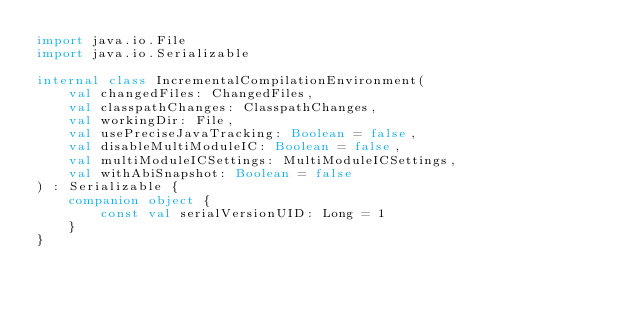<code> <loc_0><loc_0><loc_500><loc_500><_Kotlin_>import java.io.File
import java.io.Serializable

internal class IncrementalCompilationEnvironment(
    val changedFiles: ChangedFiles,
    val classpathChanges: ClasspathChanges,
    val workingDir: File,
    val usePreciseJavaTracking: Boolean = false,
    val disableMultiModuleIC: Boolean = false,
    val multiModuleICSettings: MultiModuleICSettings,
    val withAbiSnapshot: Boolean = false
) : Serializable {
    companion object {
        const val serialVersionUID: Long = 1
    }
}</code> 